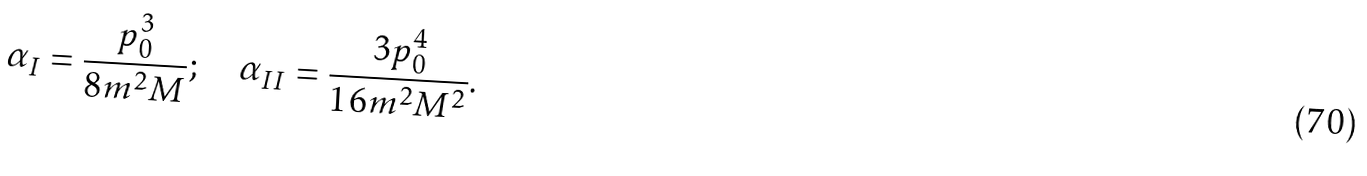Convert formula to latex. <formula><loc_0><loc_0><loc_500><loc_500>\alpha _ { I } = \frac { p _ { 0 } ^ { 3 } } { 8 m ^ { 2 } M } ; \quad \alpha _ { I I } = \frac { 3 p _ { 0 } ^ { 4 } } { 1 6 m ^ { 2 } M ^ { 2 } } .</formula> 